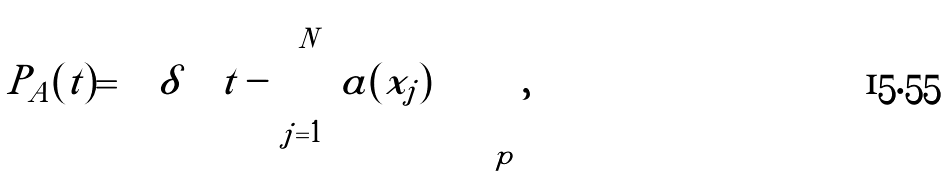<formula> <loc_0><loc_0><loc_500><loc_500>P _ { A } ( t ) = \left \langle \delta \left ( t - \sum _ { j = 1 } ^ { N } a ( x _ { j } ) \right ) \right \rangle _ { p } ,</formula> 